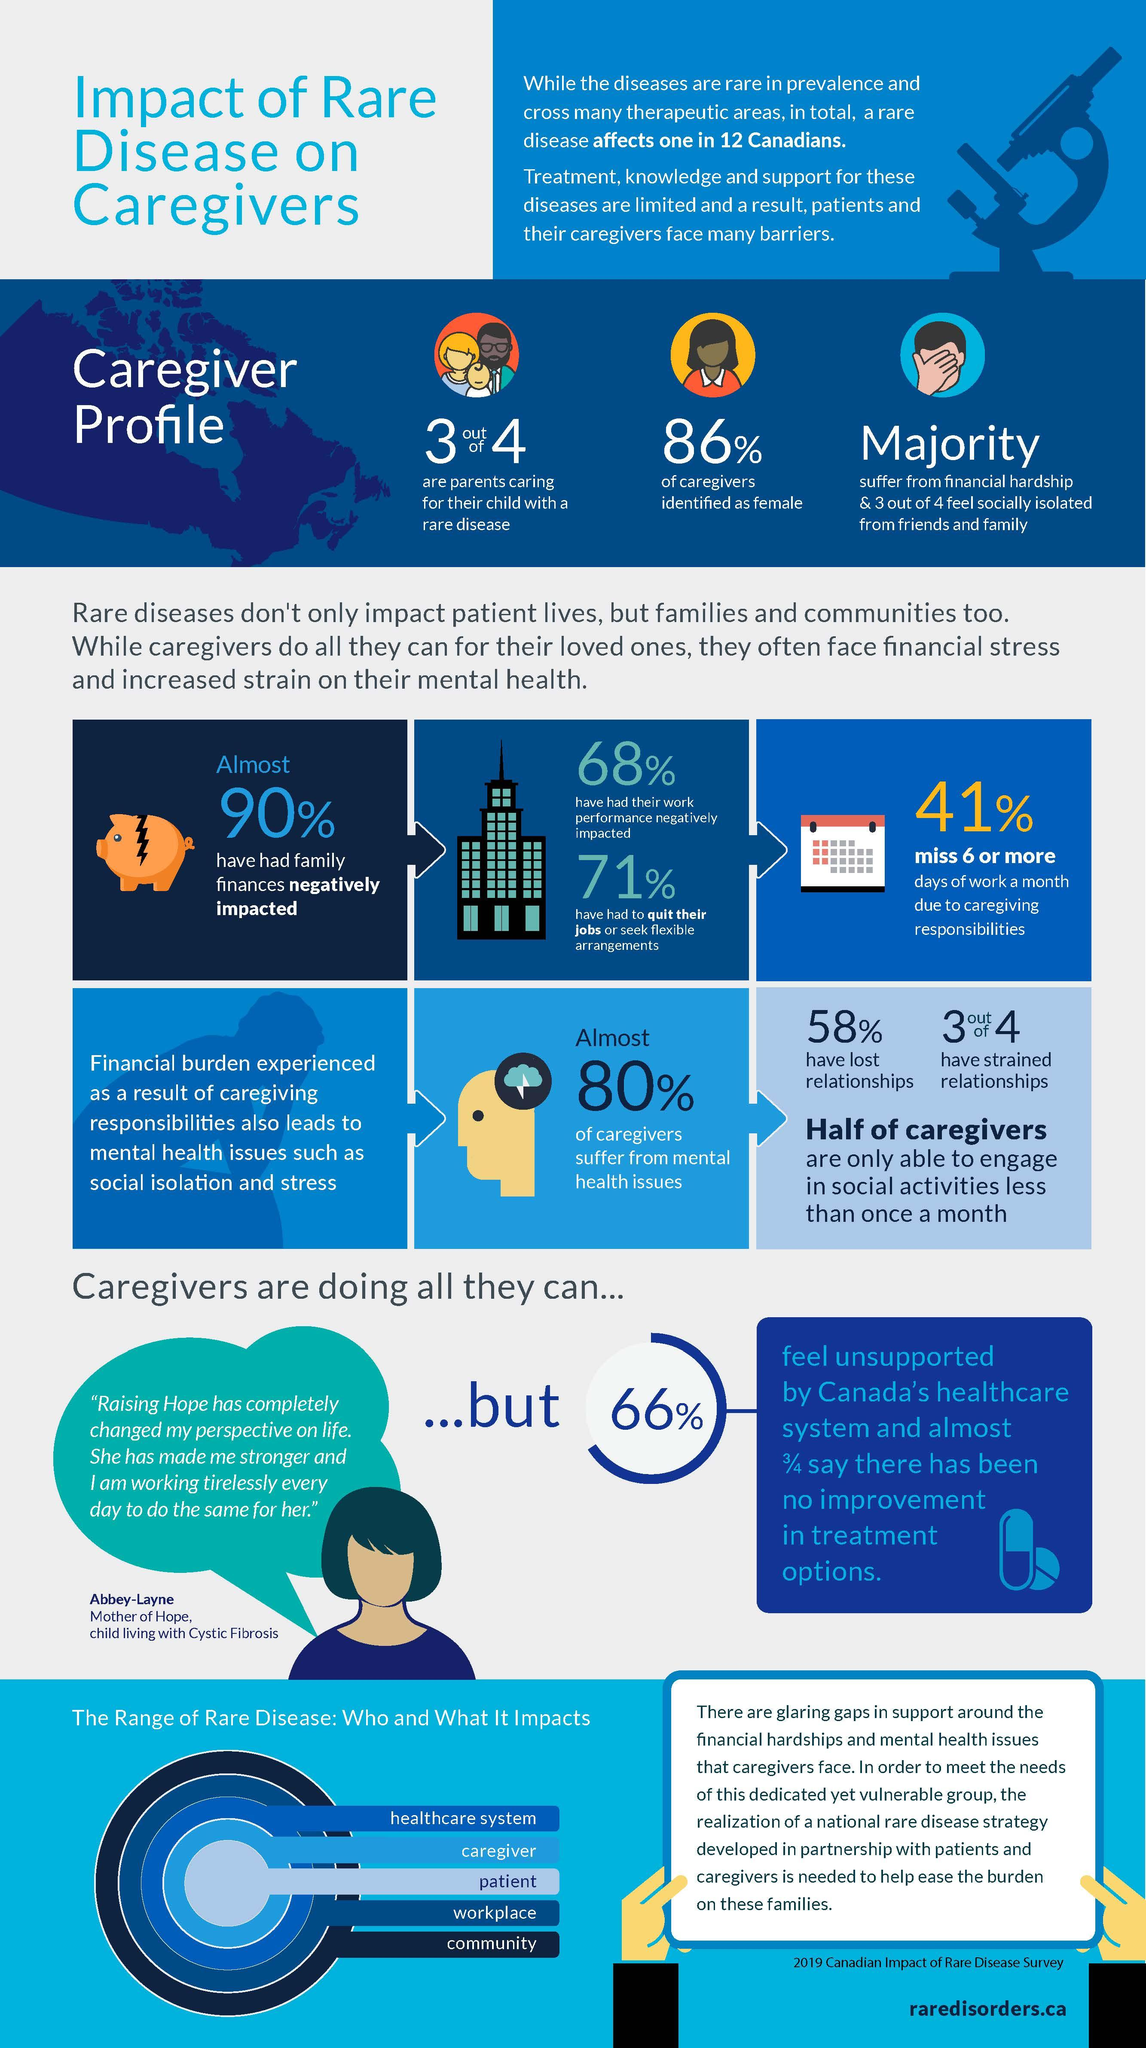Identify some key points in this picture. Seventy-five percent of caregivers have strained relationships, according to a recent study. According to a recent study, 75% of caregivers reported feeling socially isolated from their friends and family. According to a recent study, a significant percentage of parents, which amounts to 75%, are taking care of their child with a rare disease. According to the provided data, 50% of caregivers are only able to engage in social activities less than once a month. 